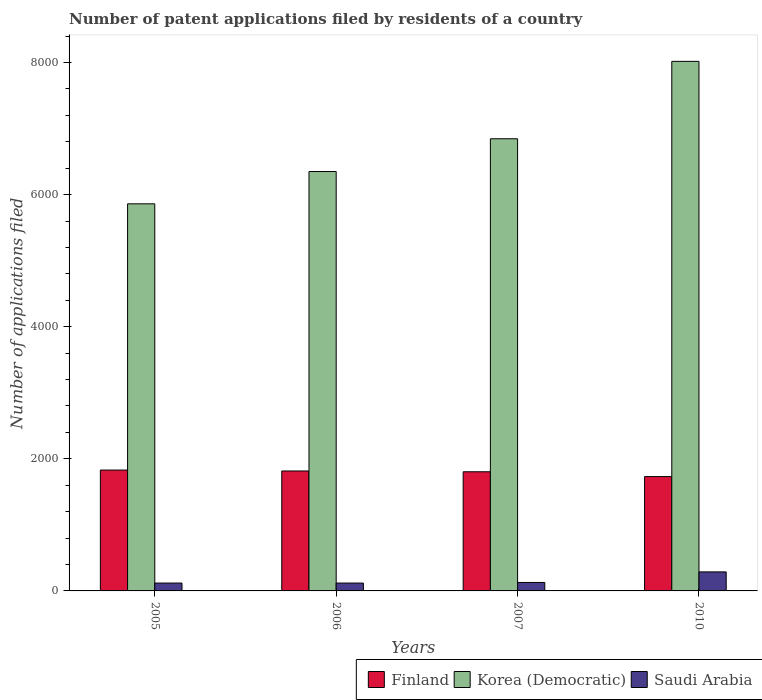How many groups of bars are there?
Offer a very short reply. 4. Are the number of bars on each tick of the X-axis equal?
Offer a very short reply. Yes. How many bars are there on the 1st tick from the left?
Your answer should be compact. 3. How many bars are there on the 1st tick from the right?
Provide a succinct answer. 3. What is the number of applications filed in Korea (Democratic) in 2005?
Offer a very short reply. 5861. Across all years, what is the maximum number of applications filed in Korea (Democratic)?
Offer a terse response. 8018. Across all years, what is the minimum number of applications filed in Finland?
Ensure brevity in your answer.  1731. In which year was the number of applications filed in Finland minimum?
Provide a succinct answer. 2010. What is the total number of applications filed in Korea (Democratic) in the graph?
Your answer should be compact. 2.71e+04. What is the difference between the number of applications filed in Korea (Democratic) in 2005 and that in 2007?
Ensure brevity in your answer.  -985. What is the difference between the number of applications filed in Saudi Arabia in 2007 and the number of applications filed in Finland in 2005?
Offer a very short reply. -1702. What is the average number of applications filed in Korea (Democratic) per year?
Your response must be concise. 6768.75. In the year 2010, what is the difference between the number of applications filed in Finland and number of applications filed in Korea (Democratic)?
Offer a very short reply. -6287. In how many years, is the number of applications filed in Finland greater than 6400?
Your answer should be compact. 0. What is the ratio of the number of applications filed in Saudi Arabia in 2005 to that in 2006?
Give a very brief answer. 1. What is the difference between the highest and the second highest number of applications filed in Finland?
Ensure brevity in your answer.  14. What is the difference between the highest and the lowest number of applications filed in Korea (Democratic)?
Keep it short and to the point. 2157. What does the 1st bar from the left in 2007 represents?
Provide a short and direct response. Finland. What does the 1st bar from the right in 2006 represents?
Give a very brief answer. Saudi Arabia. How many years are there in the graph?
Provide a succinct answer. 4. What is the difference between two consecutive major ticks on the Y-axis?
Ensure brevity in your answer.  2000. Does the graph contain any zero values?
Your answer should be compact. No. Does the graph contain grids?
Provide a succinct answer. No. Where does the legend appear in the graph?
Make the answer very short. Bottom right. How many legend labels are there?
Keep it short and to the point. 3. What is the title of the graph?
Your response must be concise. Number of patent applications filed by residents of a country. What is the label or title of the Y-axis?
Offer a terse response. Number of applications filed. What is the Number of applications filed in Finland in 2005?
Your response must be concise. 1830. What is the Number of applications filed in Korea (Democratic) in 2005?
Your response must be concise. 5861. What is the Number of applications filed of Saudi Arabia in 2005?
Keep it short and to the point. 119. What is the Number of applications filed in Finland in 2006?
Give a very brief answer. 1816. What is the Number of applications filed of Korea (Democratic) in 2006?
Make the answer very short. 6350. What is the Number of applications filed of Saudi Arabia in 2006?
Offer a very short reply. 119. What is the Number of applications filed in Finland in 2007?
Provide a short and direct response. 1804. What is the Number of applications filed of Korea (Democratic) in 2007?
Provide a succinct answer. 6846. What is the Number of applications filed in Saudi Arabia in 2007?
Keep it short and to the point. 128. What is the Number of applications filed of Finland in 2010?
Provide a short and direct response. 1731. What is the Number of applications filed in Korea (Democratic) in 2010?
Your answer should be compact. 8018. What is the Number of applications filed in Saudi Arabia in 2010?
Your answer should be compact. 288. Across all years, what is the maximum Number of applications filed in Finland?
Make the answer very short. 1830. Across all years, what is the maximum Number of applications filed in Korea (Democratic)?
Your answer should be compact. 8018. Across all years, what is the maximum Number of applications filed in Saudi Arabia?
Keep it short and to the point. 288. Across all years, what is the minimum Number of applications filed of Finland?
Keep it short and to the point. 1731. Across all years, what is the minimum Number of applications filed in Korea (Democratic)?
Your answer should be compact. 5861. Across all years, what is the minimum Number of applications filed of Saudi Arabia?
Keep it short and to the point. 119. What is the total Number of applications filed in Finland in the graph?
Ensure brevity in your answer.  7181. What is the total Number of applications filed of Korea (Democratic) in the graph?
Your answer should be very brief. 2.71e+04. What is the total Number of applications filed of Saudi Arabia in the graph?
Your answer should be very brief. 654. What is the difference between the Number of applications filed in Finland in 2005 and that in 2006?
Keep it short and to the point. 14. What is the difference between the Number of applications filed of Korea (Democratic) in 2005 and that in 2006?
Keep it short and to the point. -489. What is the difference between the Number of applications filed in Finland in 2005 and that in 2007?
Provide a succinct answer. 26. What is the difference between the Number of applications filed in Korea (Democratic) in 2005 and that in 2007?
Make the answer very short. -985. What is the difference between the Number of applications filed of Saudi Arabia in 2005 and that in 2007?
Give a very brief answer. -9. What is the difference between the Number of applications filed in Finland in 2005 and that in 2010?
Offer a terse response. 99. What is the difference between the Number of applications filed of Korea (Democratic) in 2005 and that in 2010?
Your response must be concise. -2157. What is the difference between the Number of applications filed of Saudi Arabia in 2005 and that in 2010?
Keep it short and to the point. -169. What is the difference between the Number of applications filed in Finland in 2006 and that in 2007?
Give a very brief answer. 12. What is the difference between the Number of applications filed of Korea (Democratic) in 2006 and that in 2007?
Provide a short and direct response. -496. What is the difference between the Number of applications filed in Saudi Arabia in 2006 and that in 2007?
Give a very brief answer. -9. What is the difference between the Number of applications filed of Finland in 2006 and that in 2010?
Provide a short and direct response. 85. What is the difference between the Number of applications filed of Korea (Democratic) in 2006 and that in 2010?
Make the answer very short. -1668. What is the difference between the Number of applications filed in Saudi Arabia in 2006 and that in 2010?
Provide a succinct answer. -169. What is the difference between the Number of applications filed in Korea (Democratic) in 2007 and that in 2010?
Ensure brevity in your answer.  -1172. What is the difference between the Number of applications filed in Saudi Arabia in 2007 and that in 2010?
Ensure brevity in your answer.  -160. What is the difference between the Number of applications filed in Finland in 2005 and the Number of applications filed in Korea (Democratic) in 2006?
Make the answer very short. -4520. What is the difference between the Number of applications filed of Finland in 2005 and the Number of applications filed of Saudi Arabia in 2006?
Give a very brief answer. 1711. What is the difference between the Number of applications filed in Korea (Democratic) in 2005 and the Number of applications filed in Saudi Arabia in 2006?
Provide a succinct answer. 5742. What is the difference between the Number of applications filed in Finland in 2005 and the Number of applications filed in Korea (Democratic) in 2007?
Provide a short and direct response. -5016. What is the difference between the Number of applications filed of Finland in 2005 and the Number of applications filed of Saudi Arabia in 2007?
Give a very brief answer. 1702. What is the difference between the Number of applications filed in Korea (Democratic) in 2005 and the Number of applications filed in Saudi Arabia in 2007?
Your response must be concise. 5733. What is the difference between the Number of applications filed of Finland in 2005 and the Number of applications filed of Korea (Democratic) in 2010?
Your response must be concise. -6188. What is the difference between the Number of applications filed in Finland in 2005 and the Number of applications filed in Saudi Arabia in 2010?
Ensure brevity in your answer.  1542. What is the difference between the Number of applications filed in Korea (Democratic) in 2005 and the Number of applications filed in Saudi Arabia in 2010?
Offer a terse response. 5573. What is the difference between the Number of applications filed in Finland in 2006 and the Number of applications filed in Korea (Democratic) in 2007?
Provide a succinct answer. -5030. What is the difference between the Number of applications filed of Finland in 2006 and the Number of applications filed of Saudi Arabia in 2007?
Make the answer very short. 1688. What is the difference between the Number of applications filed of Korea (Democratic) in 2006 and the Number of applications filed of Saudi Arabia in 2007?
Your response must be concise. 6222. What is the difference between the Number of applications filed in Finland in 2006 and the Number of applications filed in Korea (Democratic) in 2010?
Your response must be concise. -6202. What is the difference between the Number of applications filed of Finland in 2006 and the Number of applications filed of Saudi Arabia in 2010?
Your response must be concise. 1528. What is the difference between the Number of applications filed in Korea (Democratic) in 2006 and the Number of applications filed in Saudi Arabia in 2010?
Provide a short and direct response. 6062. What is the difference between the Number of applications filed in Finland in 2007 and the Number of applications filed in Korea (Democratic) in 2010?
Provide a short and direct response. -6214. What is the difference between the Number of applications filed of Finland in 2007 and the Number of applications filed of Saudi Arabia in 2010?
Give a very brief answer. 1516. What is the difference between the Number of applications filed in Korea (Democratic) in 2007 and the Number of applications filed in Saudi Arabia in 2010?
Your answer should be very brief. 6558. What is the average Number of applications filed in Finland per year?
Your response must be concise. 1795.25. What is the average Number of applications filed in Korea (Democratic) per year?
Your answer should be very brief. 6768.75. What is the average Number of applications filed in Saudi Arabia per year?
Offer a terse response. 163.5. In the year 2005, what is the difference between the Number of applications filed of Finland and Number of applications filed of Korea (Democratic)?
Make the answer very short. -4031. In the year 2005, what is the difference between the Number of applications filed in Finland and Number of applications filed in Saudi Arabia?
Make the answer very short. 1711. In the year 2005, what is the difference between the Number of applications filed in Korea (Democratic) and Number of applications filed in Saudi Arabia?
Ensure brevity in your answer.  5742. In the year 2006, what is the difference between the Number of applications filed of Finland and Number of applications filed of Korea (Democratic)?
Make the answer very short. -4534. In the year 2006, what is the difference between the Number of applications filed in Finland and Number of applications filed in Saudi Arabia?
Ensure brevity in your answer.  1697. In the year 2006, what is the difference between the Number of applications filed in Korea (Democratic) and Number of applications filed in Saudi Arabia?
Make the answer very short. 6231. In the year 2007, what is the difference between the Number of applications filed of Finland and Number of applications filed of Korea (Democratic)?
Your response must be concise. -5042. In the year 2007, what is the difference between the Number of applications filed of Finland and Number of applications filed of Saudi Arabia?
Provide a short and direct response. 1676. In the year 2007, what is the difference between the Number of applications filed of Korea (Democratic) and Number of applications filed of Saudi Arabia?
Ensure brevity in your answer.  6718. In the year 2010, what is the difference between the Number of applications filed in Finland and Number of applications filed in Korea (Democratic)?
Offer a very short reply. -6287. In the year 2010, what is the difference between the Number of applications filed in Finland and Number of applications filed in Saudi Arabia?
Keep it short and to the point. 1443. In the year 2010, what is the difference between the Number of applications filed in Korea (Democratic) and Number of applications filed in Saudi Arabia?
Your answer should be compact. 7730. What is the ratio of the Number of applications filed in Finland in 2005 to that in 2006?
Ensure brevity in your answer.  1.01. What is the ratio of the Number of applications filed of Korea (Democratic) in 2005 to that in 2006?
Give a very brief answer. 0.92. What is the ratio of the Number of applications filed of Finland in 2005 to that in 2007?
Offer a very short reply. 1.01. What is the ratio of the Number of applications filed in Korea (Democratic) in 2005 to that in 2007?
Your answer should be compact. 0.86. What is the ratio of the Number of applications filed of Saudi Arabia in 2005 to that in 2007?
Your answer should be compact. 0.93. What is the ratio of the Number of applications filed of Finland in 2005 to that in 2010?
Your response must be concise. 1.06. What is the ratio of the Number of applications filed in Korea (Democratic) in 2005 to that in 2010?
Offer a very short reply. 0.73. What is the ratio of the Number of applications filed in Saudi Arabia in 2005 to that in 2010?
Give a very brief answer. 0.41. What is the ratio of the Number of applications filed in Korea (Democratic) in 2006 to that in 2007?
Provide a short and direct response. 0.93. What is the ratio of the Number of applications filed in Saudi Arabia in 2006 to that in 2007?
Your response must be concise. 0.93. What is the ratio of the Number of applications filed of Finland in 2006 to that in 2010?
Your response must be concise. 1.05. What is the ratio of the Number of applications filed of Korea (Democratic) in 2006 to that in 2010?
Your answer should be very brief. 0.79. What is the ratio of the Number of applications filed of Saudi Arabia in 2006 to that in 2010?
Provide a short and direct response. 0.41. What is the ratio of the Number of applications filed in Finland in 2007 to that in 2010?
Provide a succinct answer. 1.04. What is the ratio of the Number of applications filed in Korea (Democratic) in 2007 to that in 2010?
Keep it short and to the point. 0.85. What is the ratio of the Number of applications filed in Saudi Arabia in 2007 to that in 2010?
Make the answer very short. 0.44. What is the difference between the highest and the second highest Number of applications filed in Finland?
Make the answer very short. 14. What is the difference between the highest and the second highest Number of applications filed in Korea (Democratic)?
Give a very brief answer. 1172. What is the difference between the highest and the second highest Number of applications filed in Saudi Arabia?
Provide a short and direct response. 160. What is the difference between the highest and the lowest Number of applications filed in Korea (Democratic)?
Your response must be concise. 2157. What is the difference between the highest and the lowest Number of applications filed of Saudi Arabia?
Offer a terse response. 169. 